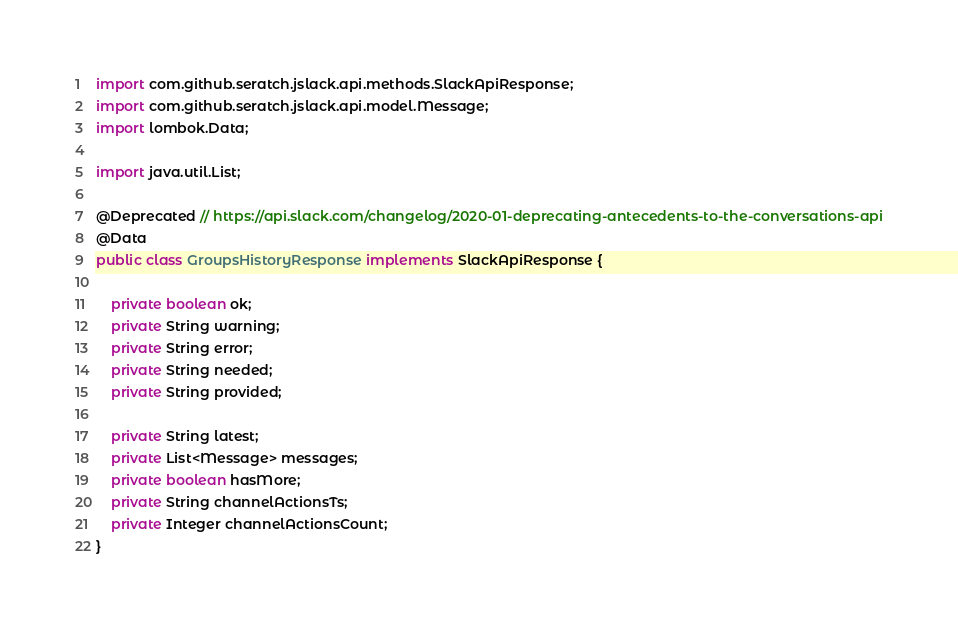Convert code to text. <code><loc_0><loc_0><loc_500><loc_500><_Java_>import com.github.seratch.jslack.api.methods.SlackApiResponse;
import com.github.seratch.jslack.api.model.Message;
import lombok.Data;

import java.util.List;

@Deprecated // https://api.slack.com/changelog/2020-01-deprecating-antecedents-to-the-conversations-api
@Data
public class GroupsHistoryResponse implements SlackApiResponse {

    private boolean ok;
    private String warning;
    private String error;
    private String needed;
    private String provided;

    private String latest;
    private List<Message> messages;
    private boolean hasMore;
    private String channelActionsTs;
    private Integer channelActionsCount;
}</code> 